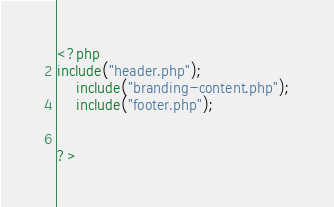<code> <loc_0><loc_0><loc_500><loc_500><_PHP_><?php
include("header.php");
	include("branding-content.php");
	include("footer.php");


?></code> 